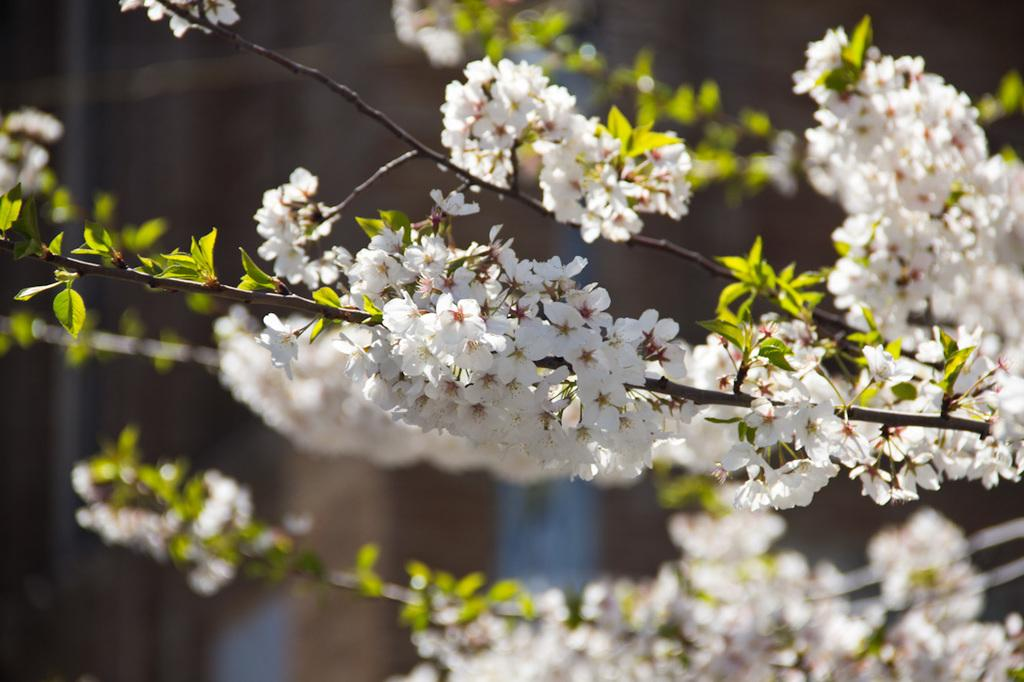What is present in the image related to vegetation? There is a plant in the image. What specific feature of the plant can be observed? The plant has a group of flowers. What color are the flowers? The flowers are white in color. Can you describe the background of the image? There is an unclear object or element behind the plant. Can you tell me if the plant has received approval from a regulatory agency in the image? There is no indication in the image that the plant has received approval from any regulatory agency. 